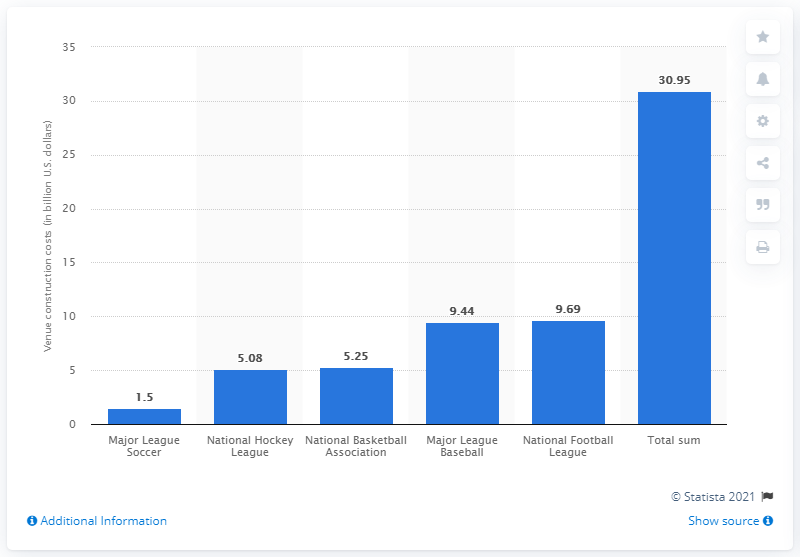Draw attention to some important aspects in this diagram. The total amount spent on venue construction for the National Hockey League between 1989 and 2009 was 5.08 billion dollars. 